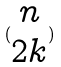<formula> <loc_0><loc_0><loc_500><loc_500>( \begin{matrix} n \\ 2 k \end{matrix} )</formula> 